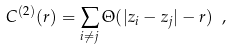<formula> <loc_0><loc_0><loc_500><loc_500>C ^ { ( 2 ) } ( r ) = \sum _ { i \ne j } \Theta ( | z _ { i } - z _ { j } | - r ) \ ,</formula> 